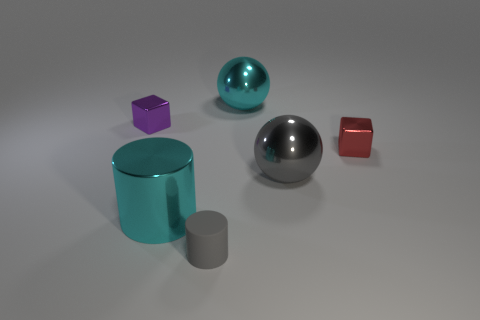Add 1 rubber cylinders. How many objects exist? 7 Subtract all spheres. How many objects are left? 4 Add 1 big blue rubber cubes. How many big blue rubber cubes exist? 1 Subtract 1 purple blocks. How many objects are left? 5 Subtract all small blue things. Subtract all purple metallic things. How many objects are left? 5 Add 5 blocks. How many blocks are left? 7 